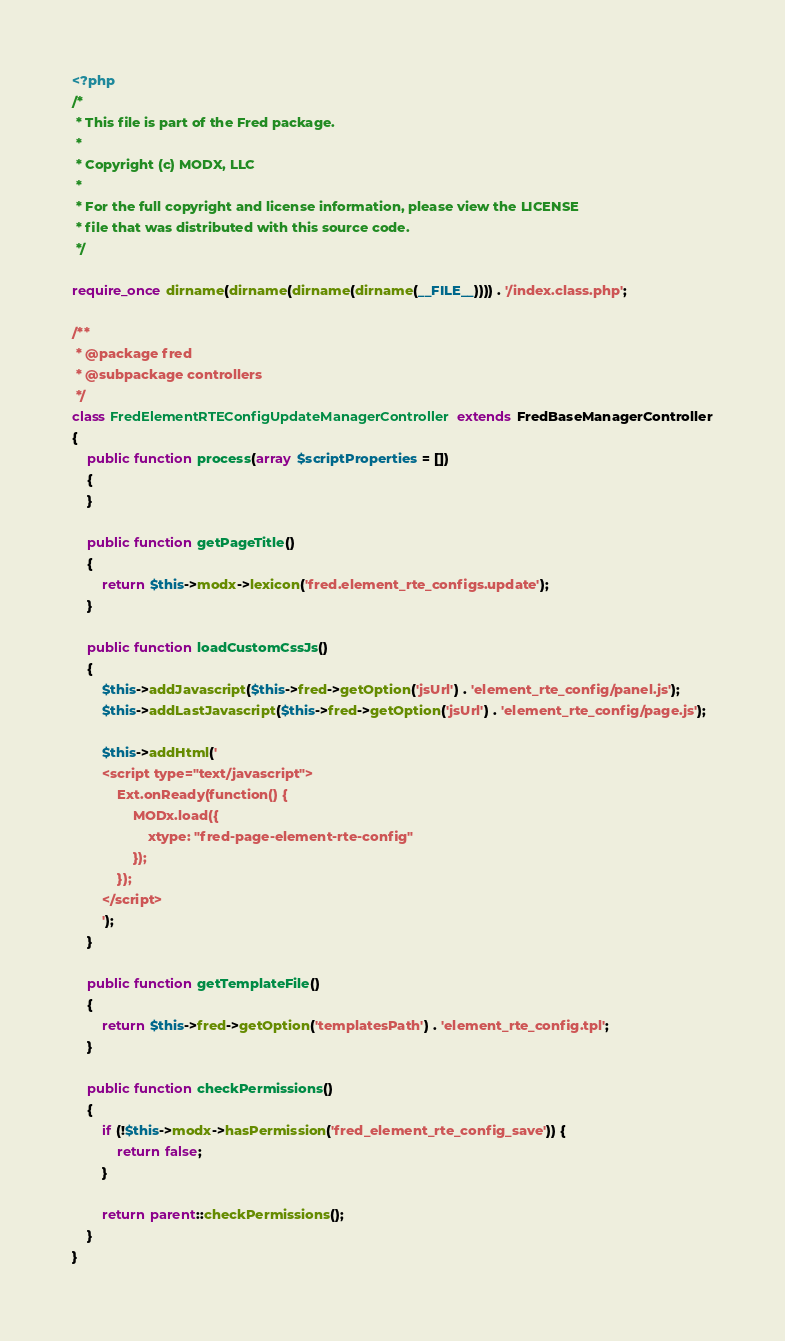Convert code to text. <code><loc_0><loc_0><loc_500><loc_500><_PHP_><?php
/*
 * This file is part of the Fred package.
 *
 * Copyright (c) MODX, LLC
 *
 * For the full copyright and license information, please view the LICENSE
 * file that was distributed with this source code.
 */

require_once dirname(dirname(dirname(dirname(__FILE__)))) . '/index.class.php';

/**
 * @package fred
 * @subpackage controllers
 */
class FredElementRTEConfigUpdateManagerController extends FredBaseManagerController
{
    public function process(array $scriptProperties = [])
    {
    }

    public function getPageTitle()
    {
        return $this->modx->lexicon('fred.element_rte_configs.update');
    }

    public function loadCustomCssJs()
    {
        $this->addJavascript($this->fred->getOption('jsUrl') . 'element_rte_config/panel.js');
        $this->addLastJavascript($this->fred->getOption('jsUrl') . 'element_rte_config/page.js');

        $this->addHtml('
        <script type="text/javascript">
            Ext.onReady(function() {
                MODx.load({ 
                    xtype: "fred-page-element-rte-config"
                });
            });
        </script>
        ');
    }

    public function getTemplateFile()
    {
        return $this->fred->getOption('templatesPath') . 'element_rte_config.tpl';
    }

    public function checkPermissions()
    {
        if (!$this->modx->hasPermission('fred_element_rte_config_save')) {
            return false;
        }

        return parent::checkPermissions();
    }
}
</code> 